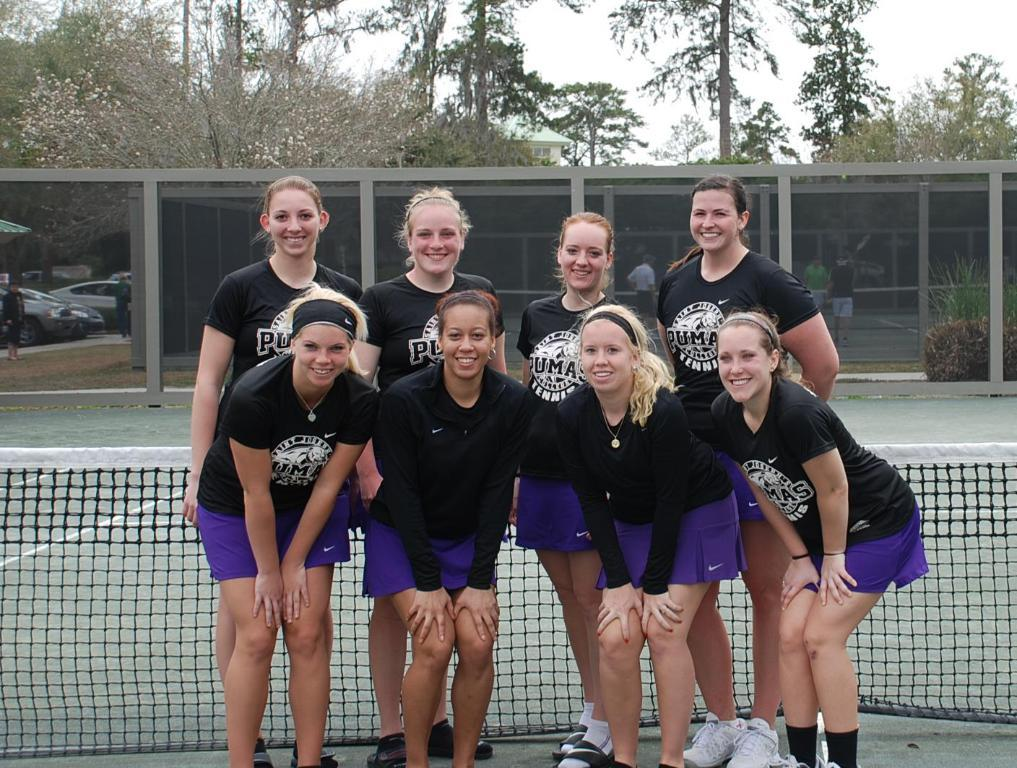<image>
Relay a brief, clear account of the picture shown. Teenage girls in front of tennis net wearing black Puma Tennis tshirts 